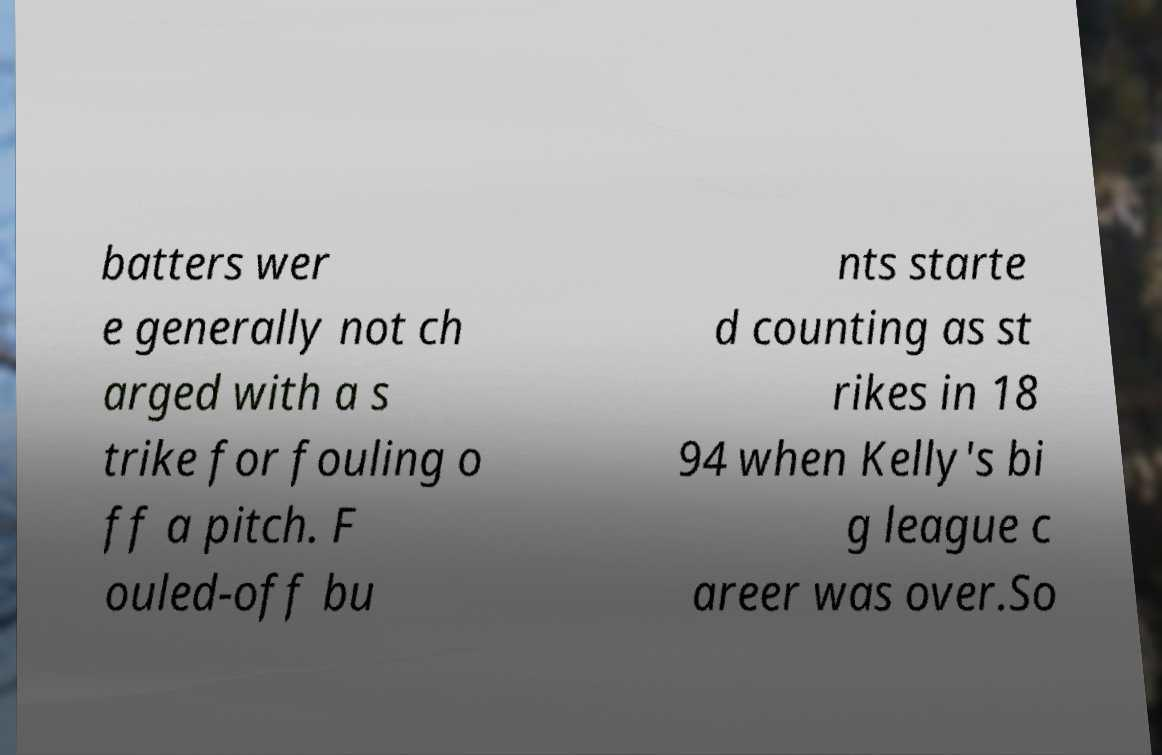What messages or text are displayed in this image? I need them in a readable, typed format. batters wer e generally not ch arged with a s trike for fouling o ff a pitch. F ouled-off bu nts starte d counting as st rikes in 18 94 when Kelly's bi g league c areer was over.So 